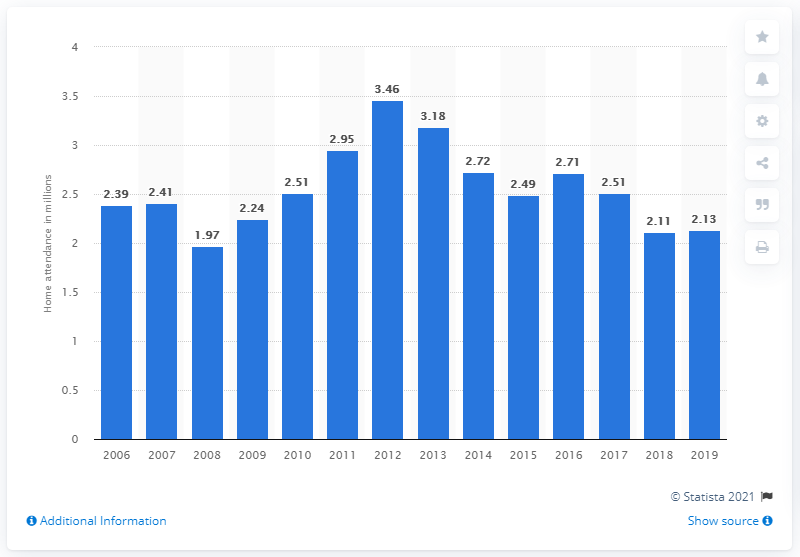Identify some key points in this picture. The Texas Rangers' regular season home attendance in 2019 was 2.13 million. 